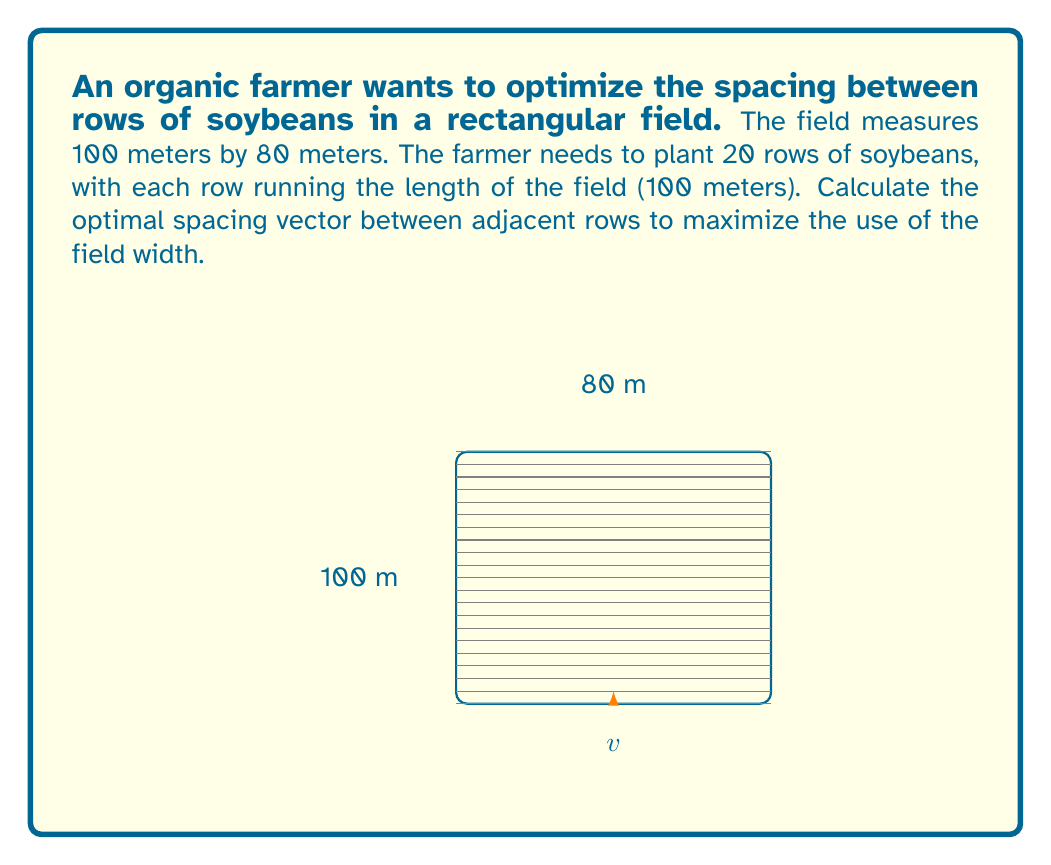Teach me how to tackle this problem. To solve this problem, we need to follow these steps:

1) First, we need to understand that the spacing vector will be perpendicular to the rows and parallel to the width of the field.

2) The magnitude of this vector will be the distance between adjacent rows.

3) Since we need to fit 20 rows in the 80-meter width of the field, we can calculate the spacing as follows:

   $$\text{Spacing} = \frac{\text{Field width}}{\text{Number of spaces}}$$

   Where the number of spaces is one less than the number of rows.

4) Calculating:
   $$\text{Spacing} = \frac{80 \text{ m}}{20 - 1} = \frac{80 \text{ m}}{19} = 4.21 \text{ m}$$

5) The spacing vector will have this magnitude and will be directed along the width of the field. In vector notation, if we consider the length of the field to be along the x-axis and the width along the y-axis, our vector will be:

   $$\vec{v} = \langle 0, 4.21 \rangle$$

   This represents no movement along the x-axis (length) and 4.21 meters along the y-axis (width).
Answer: $\vec{v} = \langle 0, 4.21 \rangle$ meters 